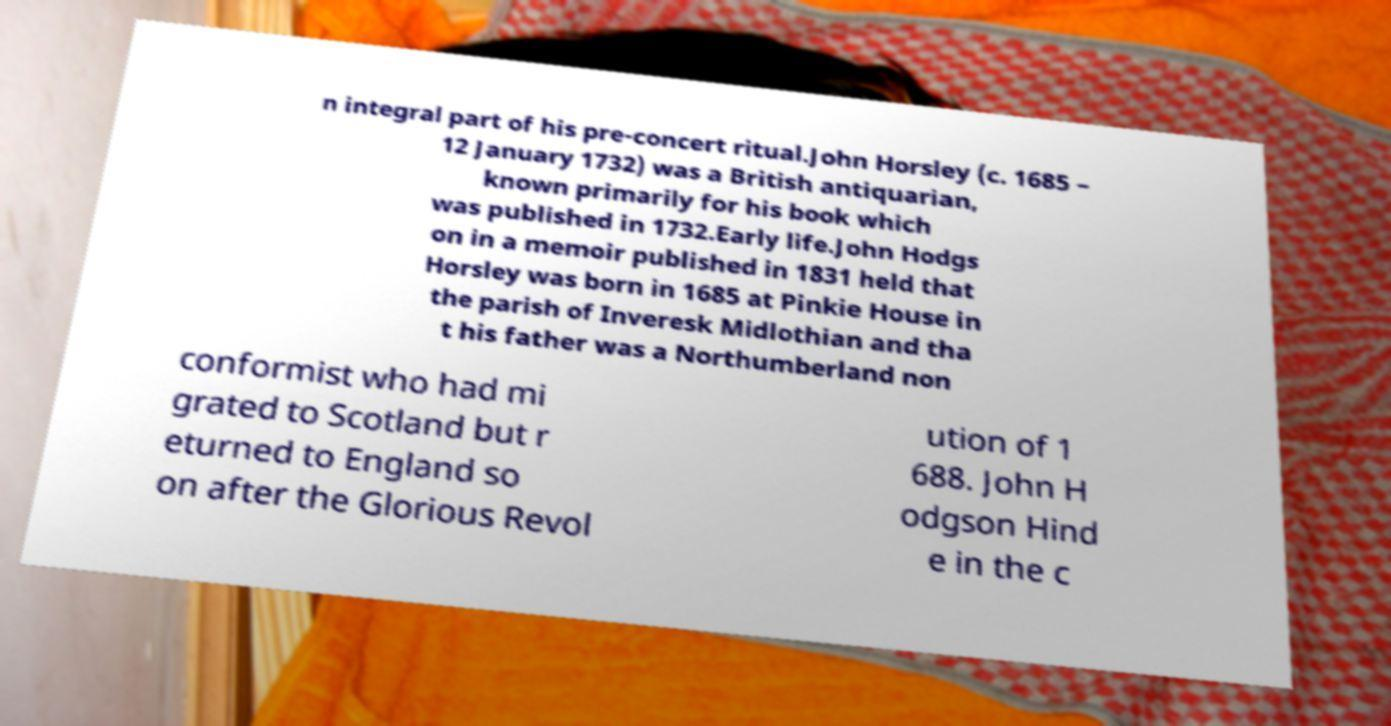I need the written content from this picture converted into text. Can you do that? n integral part of his pre-concert ritual.John Horsley (c. 1685 – 12 January 1732) was a British antiquarian, known primarily for his book which was published in 1732.Early life.John Hodgs on in a memoir published in 1831 held that Horsley was born in 1685 at Pinkie House in the parish of Inveresk Midlothian and tha t his father was a Northumberland non conformist who had mi grated to Scotland but r eturned to England so on after the Glorious Revol ution of 1 688. John H odgson Hind e in the c 